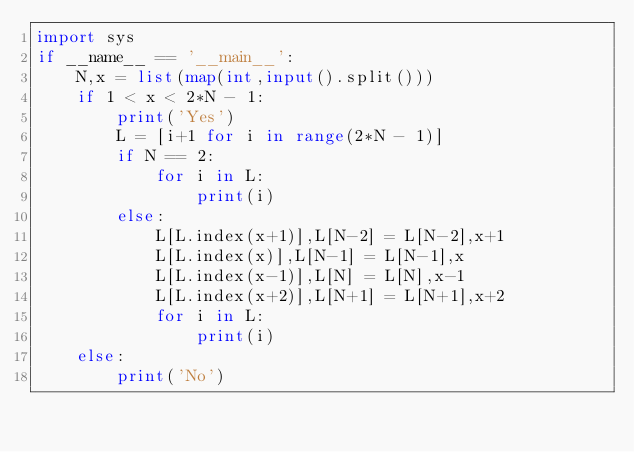<code> <loc_0><loc_0><loc_500><loc_500><_Python_>import sys
if __name__ == '__main__':
    N,x = list(map(int,input().split()))
    if 1 < x < 2*N - 1:
        print('Yes')
        L = [i+1 for i in range(2*N - 1)]
        if N == 2:
            for i in L:
                print(i)
        else:
            L[L.index(x+1)],L[N-2] = L[N-2],x+1
            L[L.index(x)],L[N-1] = L[N-1],x
            L[L.index(x-1)],L[N] = L[N],x-1
            L[L.index(x+2)],L[N+1] = L[N+1],x+2
            for i in L:
                print(i)
    else:
        print('No')
</code> 